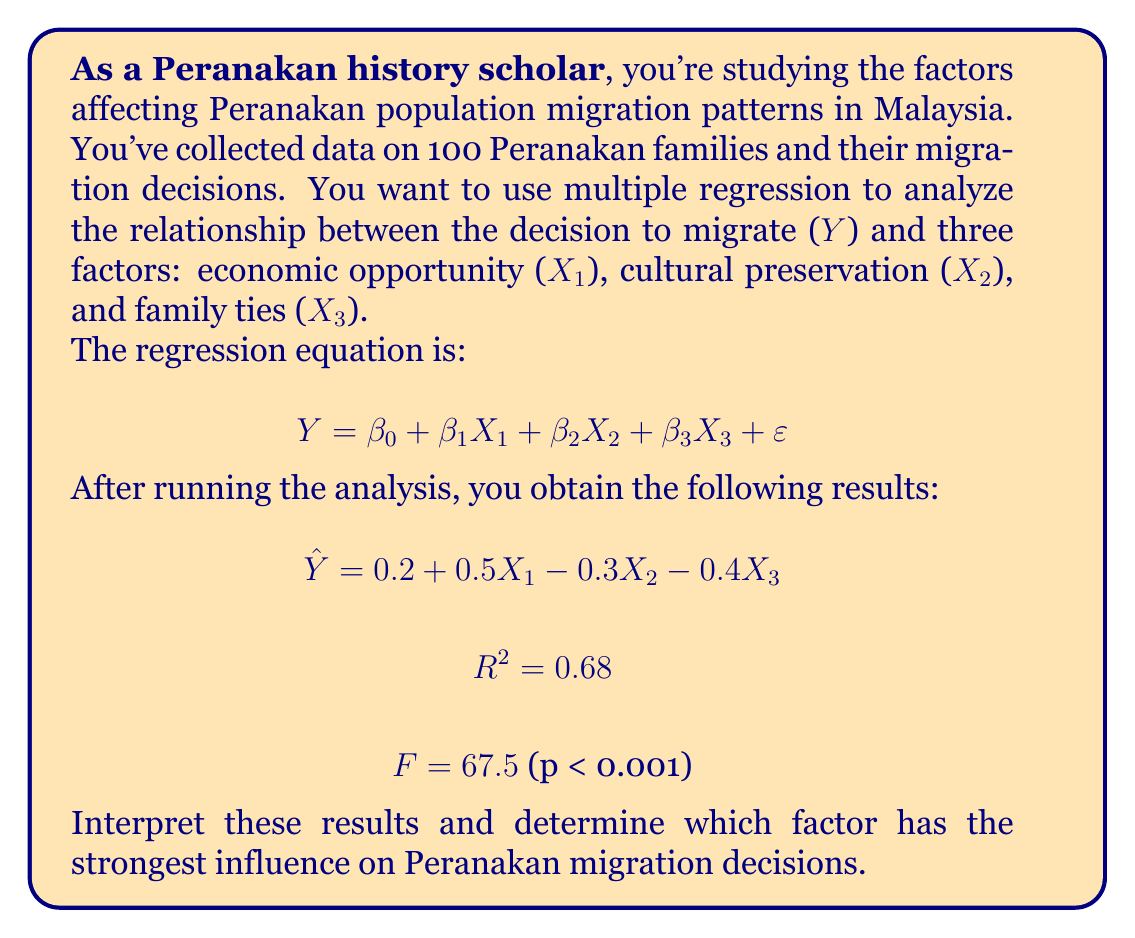Show me your answer to this math problem. To interpret the results and determine the strongest influencing factor, we'll follow these steps:

1. Interpret the regression coefficients (β values):
   - β₁ = 0.5: A one-unit increase in economic opportunity is associated with a 0.5 unit increase in the likelihood of migration.
   - β₂ = -0.3: A one-unit increase in cultural preservation is associated with a 0.3 unit decrease in the likelihood of migration.
   - β₃ = -0.4: A one-unit increase in family ties is associated with a 0.4 unit decrease in the likelihood of migration.

2. Evaluate the overall model fit:
   - R² = 0.68 indicates that 68% of the variation in migration decisions can be explained by these three factors.
   - F = 67.5 with p < 0.001 suggests that the model is statistically significant.

3. Compare the absolute values of the coefficients to determine the strongest influence:
   |β₁| = 0.5
   |β₂| = 0.3
   |β₃| = 0.4

4. The largest absolute value is |β₁| = 0.5, corresponding to economic opportunity.

Therefore, economic opportunity (X₁) has the strongest influence on Peranakan migration decisions. It has the largest absolute coefficient value and a positive relationship with migration likelihood.
Answer: Economic opportunity has the strongest influence on Peranakan migration decisions. 